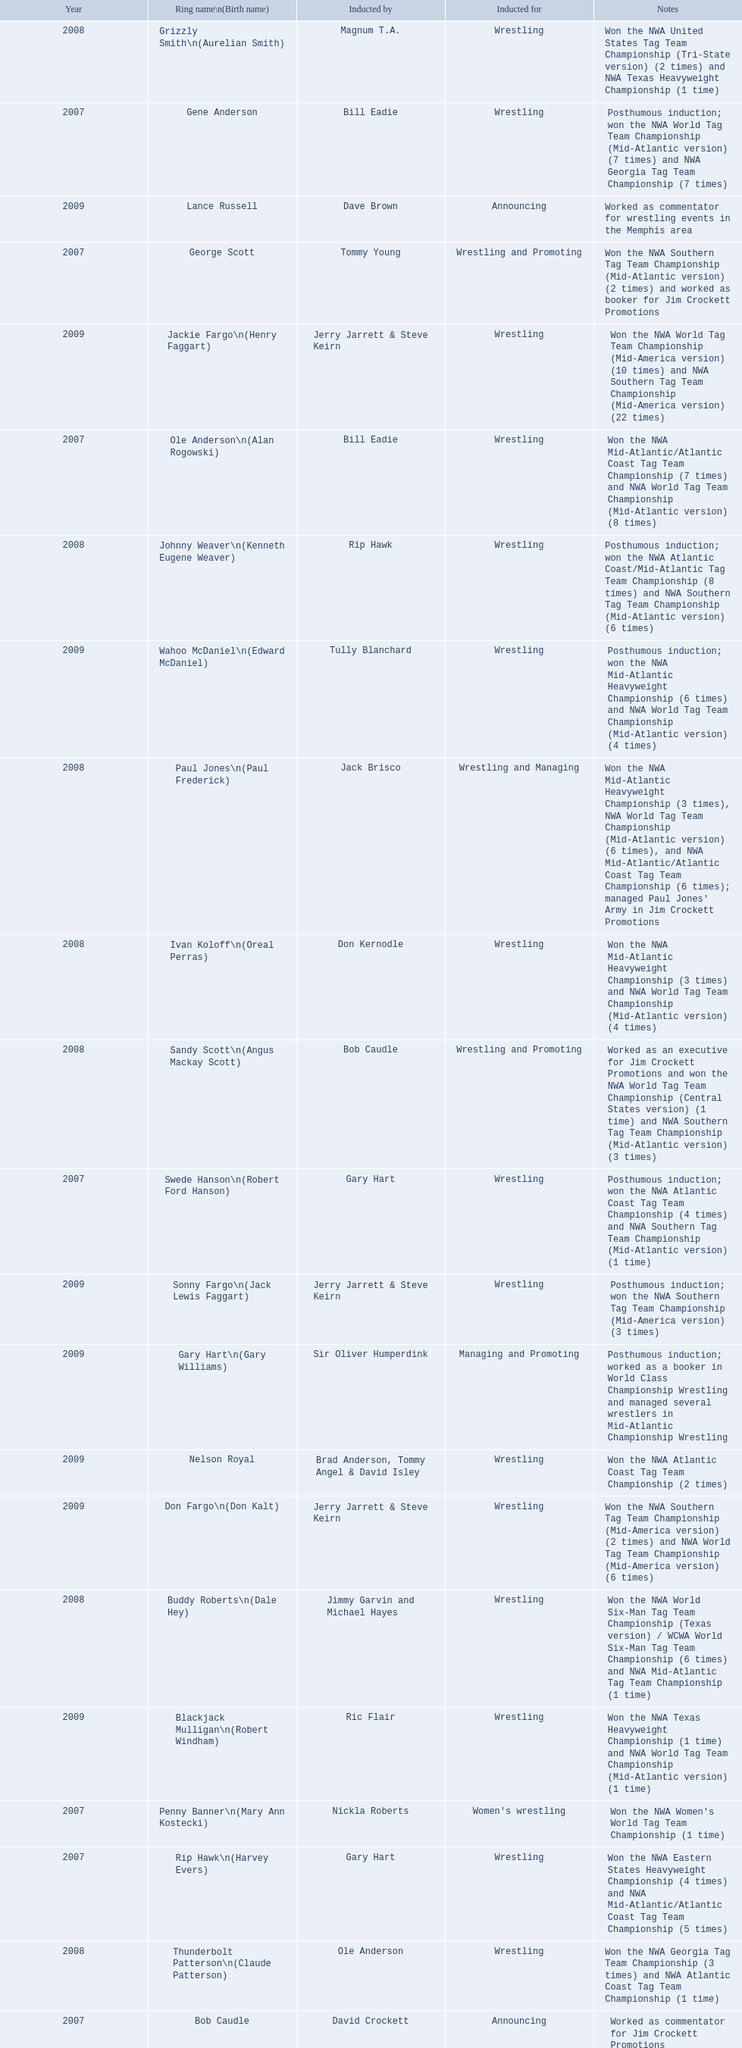What announcers were inducted? Bob Caudle, Lance Russell. What announcer was inducted in 2009? Lance Russell. 